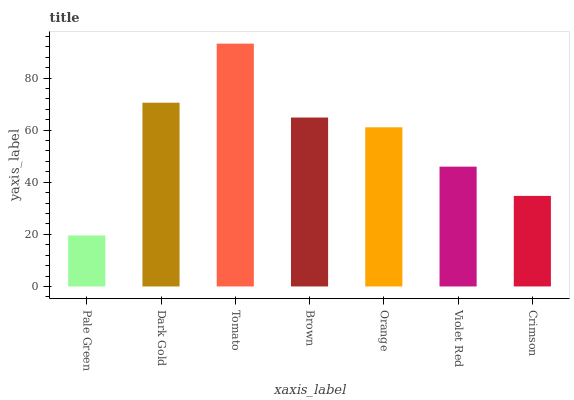Is Dark Gold the minimum?
Answer yes or no. No. Is Dark Gold the maximum?
Answer yes or no. No. Is Dark Gold greater than Pale Green?
Answer yes or no. Yes. Is Pale Green less than Dark Gold?
Answer yes or no. Yes. Is Pale Green greater than Dark Gold?
Answer yes or no. No. Is Dark Gold less than Pale Green?
Answer yes or no. No. Is Orange the high median?
Answer yes or no. Yes. Is Orange the low median?
Answer yes or no. Yes. Is Tomato the high median?
Answer yes or no. No. Is Pale Green the low median?
Answer yes or no. No. 